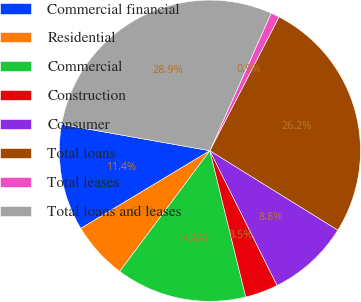<chart> <loc_0><loc_0><loc_500><loc_500><pie_chart><fcel>Commercial financial<fcel>Residential<fcel>Commercial<fcel>Construction<fcel>Consumer<fcel>Total loans<fcel>Total leases<fcel>Total loans and leases<nl><fcel>11.42%<fcel>6.17%<fcel>14.04%<fcel>3.54%<fcel>8.79%<fcel>26.25%<fcel>0.92%<fcel>28.88%<nl></chart> 